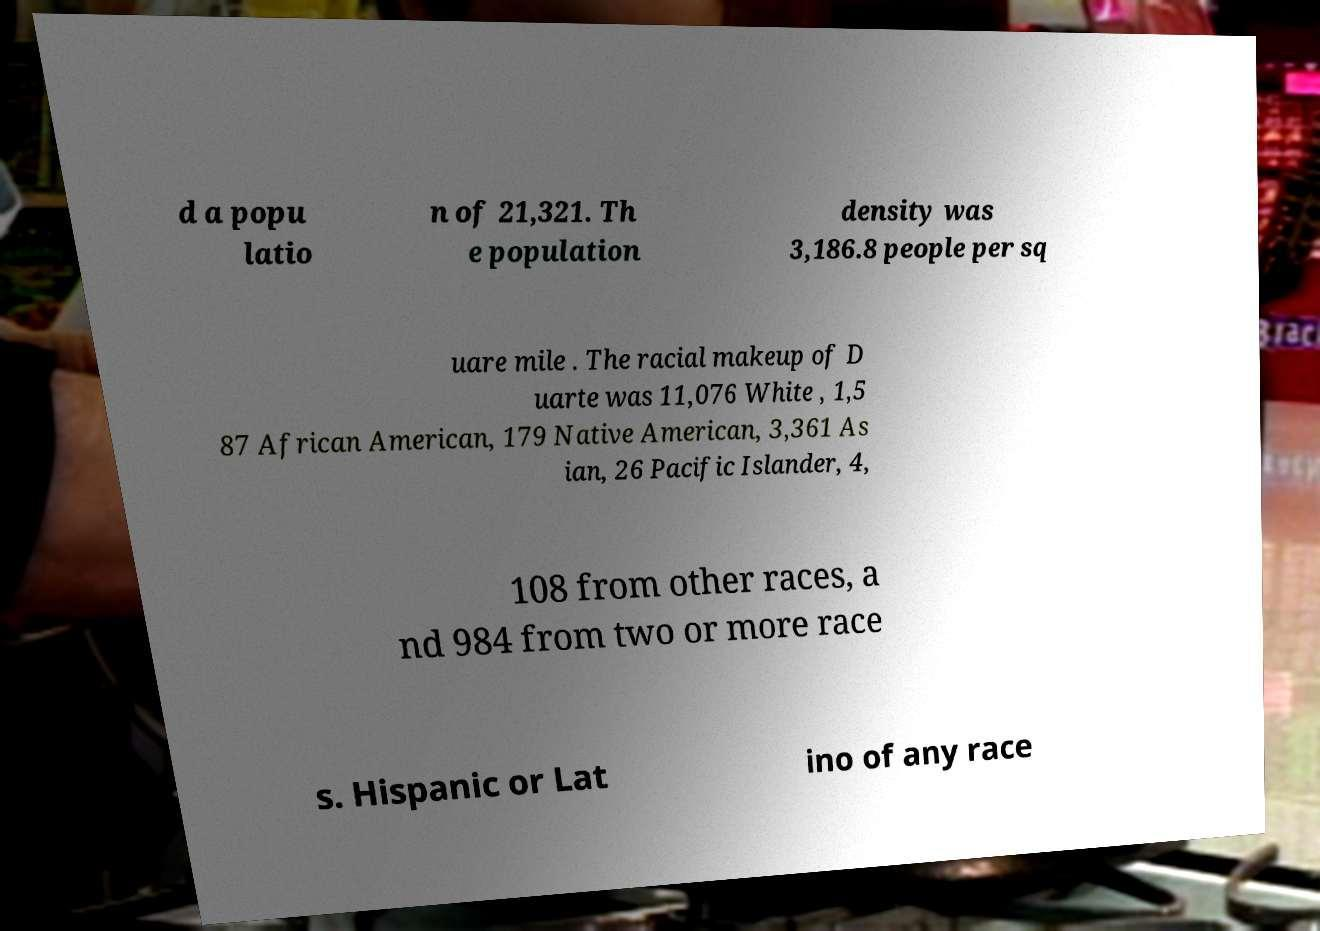Please identify and transcribe the text found in this image. d a popu latio n of 21,321. Th e population density was 3,186.8 people per sq uare mile . The racial makeup of D uarte was 11,076 White , 1,5 87 African American, 179 Native American, 3,361 As ian, 26 Pacific Islander, 4, 108 from other races, a nd 984 from two or more race s. Hispanic or Lat ino of any race 